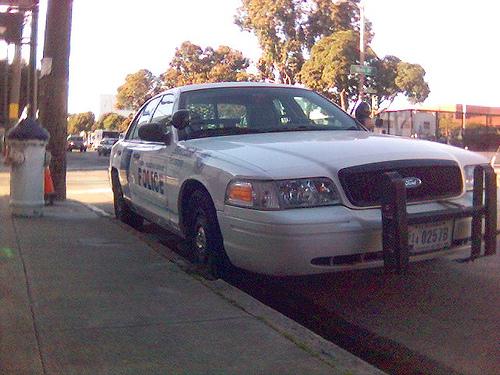What side of the road do they drive on?
Write a very short answer. Right. Is this indoors?
Concise answer only. No. Is this vehicle breaking the law?
Quick response, please. Yes. What type of car is this?
Give a very brief answer. Police. 